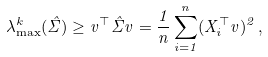Convert formula to latex. <formula><loc_0><loc_0><loc_500><loc_500>\lambda ^ { k } _ { \max } ( \hat { \Sigma } ) \geq v ^ { \top } \hat { \Sigma } v = \frac { 1 } { n } \sum _ { i = 1 } ^ { n } ( X _ { i } ^ { \top } v ) ^ { 2 } \, ,</formula> 